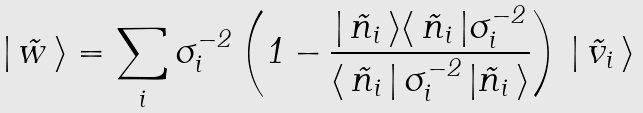<formula> <loc_0><loc_0><loc_500><loc_500>| \, \vec { w } \, \rangle = \sum _ { i } { \boldmath \sigma } _ { i } ^ { - 2 } \left ( { \boldmath 1 } - \frac { | \, \vec { n } _ { i } \, \rangle \langle \, \vec { n } _ { i } \, | { \boldmath \sigma } _ { i } ^ { - 2 } } { \langle \, \vec { n } _ { i } \, | \, { \boldmath \sigma } _ { i } ^ { - 2 } \, | \vec { n } _ { i } \, \rangle } \right ) \, | \, \vec { v } _ { i } \, \rangle</formula> 